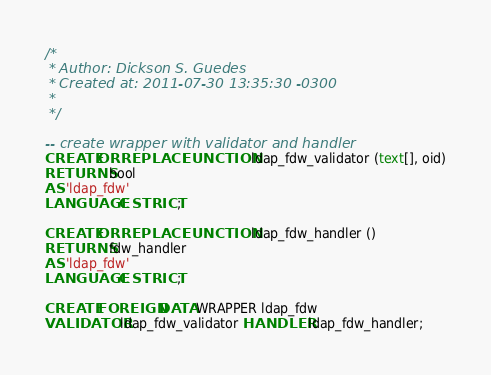<code> <loc_0><loc_0><loc_500><loc_500><_SQL_>/*
 * Author: Dickson S. Guedes
 * Created at: 2011-07-30 13:35:30 -0300
 *
 */ 

-- create wrapper with validator and handler
CREATE OR REPLACE FUNCTION ldap_fdw_validator (text[], oid)
RETURNS bool
AS 'ldap_fdw'
LANGUAGE C STRICT;

CREATE OR REPLACE FUNCTION ldap_fdw_handler ()
RETURNS fdw_handler
AS 'ldap_fdw'
LANGUAGE C STRICT;

CREATE FOREIGN DATA WRAPPER ldap_fdw
VALIDATOR ldap_fdw_validator HANDLER ldap_fdw_handler;

</code> 